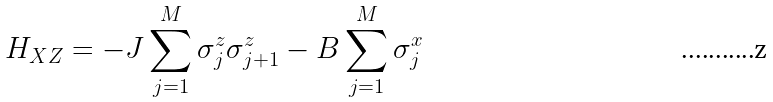Convert formula to latex. <formula><loc_0><loc_0><loc_500><loc_500>H _ { X Z } = - J \sum _ { j = 1 } ^ { M } \sigma ^ { z } _ { j } \sigma ^ { z } _ { j + 1 } - B \sum _ { j = 1 } ^ { M } \sigma ^ { x } _ { j }</formula> 